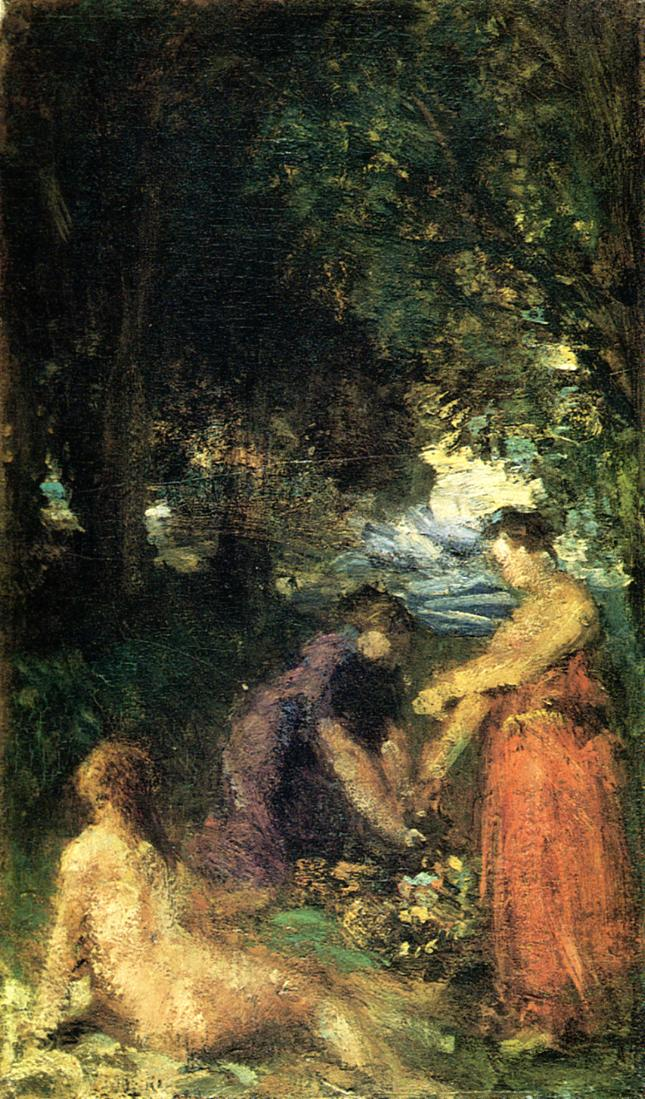What do you think is going on in this snapshot? This painting evokes the essence of an impressionist artwork, capturing a serene and intimate scene set in a dense forest. Dominated by rich greens and browns, the artist skillfully employs loose brushstrokes to bring vitality to the scene. In a clearing, a small group of people, likely enjoying a leisurely day in nature, is depicted. One of the intriguing elements is a small patch of blue sky peeping through the verdant canopy, adding contrast to the overall earthy tones.

The composition suggests different levels of focus: the figures in the foreground are more defined, with discernible features and clothing, while those farther away blend seamlessly into the background, indicated rather than explicitly shown. This technique enhances the sense of depth and movement in the image.

Given the stylistic elements and the subject matter, this artwork probably dates back to the late 19th or early 20th century, a period where Impressionism flourished. This genre aimed to capture the fleeting impressions of everyday life, and the painting invites the viewer into a tranquil and seemingly timeless moment shared among companions in a natural setting. 